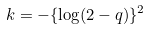<formula> <loc_0><loc_0><loc_500><loc_500>k = - \{ \log ( 2 - q ) \} ^ { 2 }</formula> 